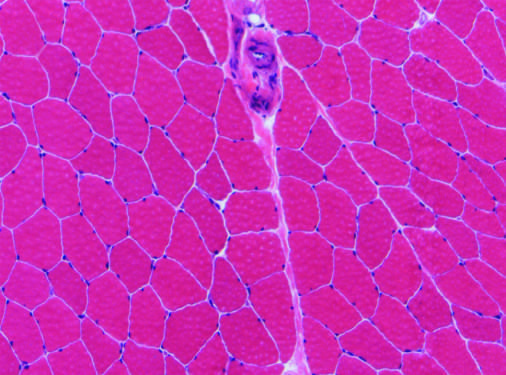does normal skeletal muscle have relatively uniform polygonal myofibers with peripherally placed nuclei that are tightly packed together into fascicles separated by scant connective tissue?
Answer the question using a single word or phrase. Yes 